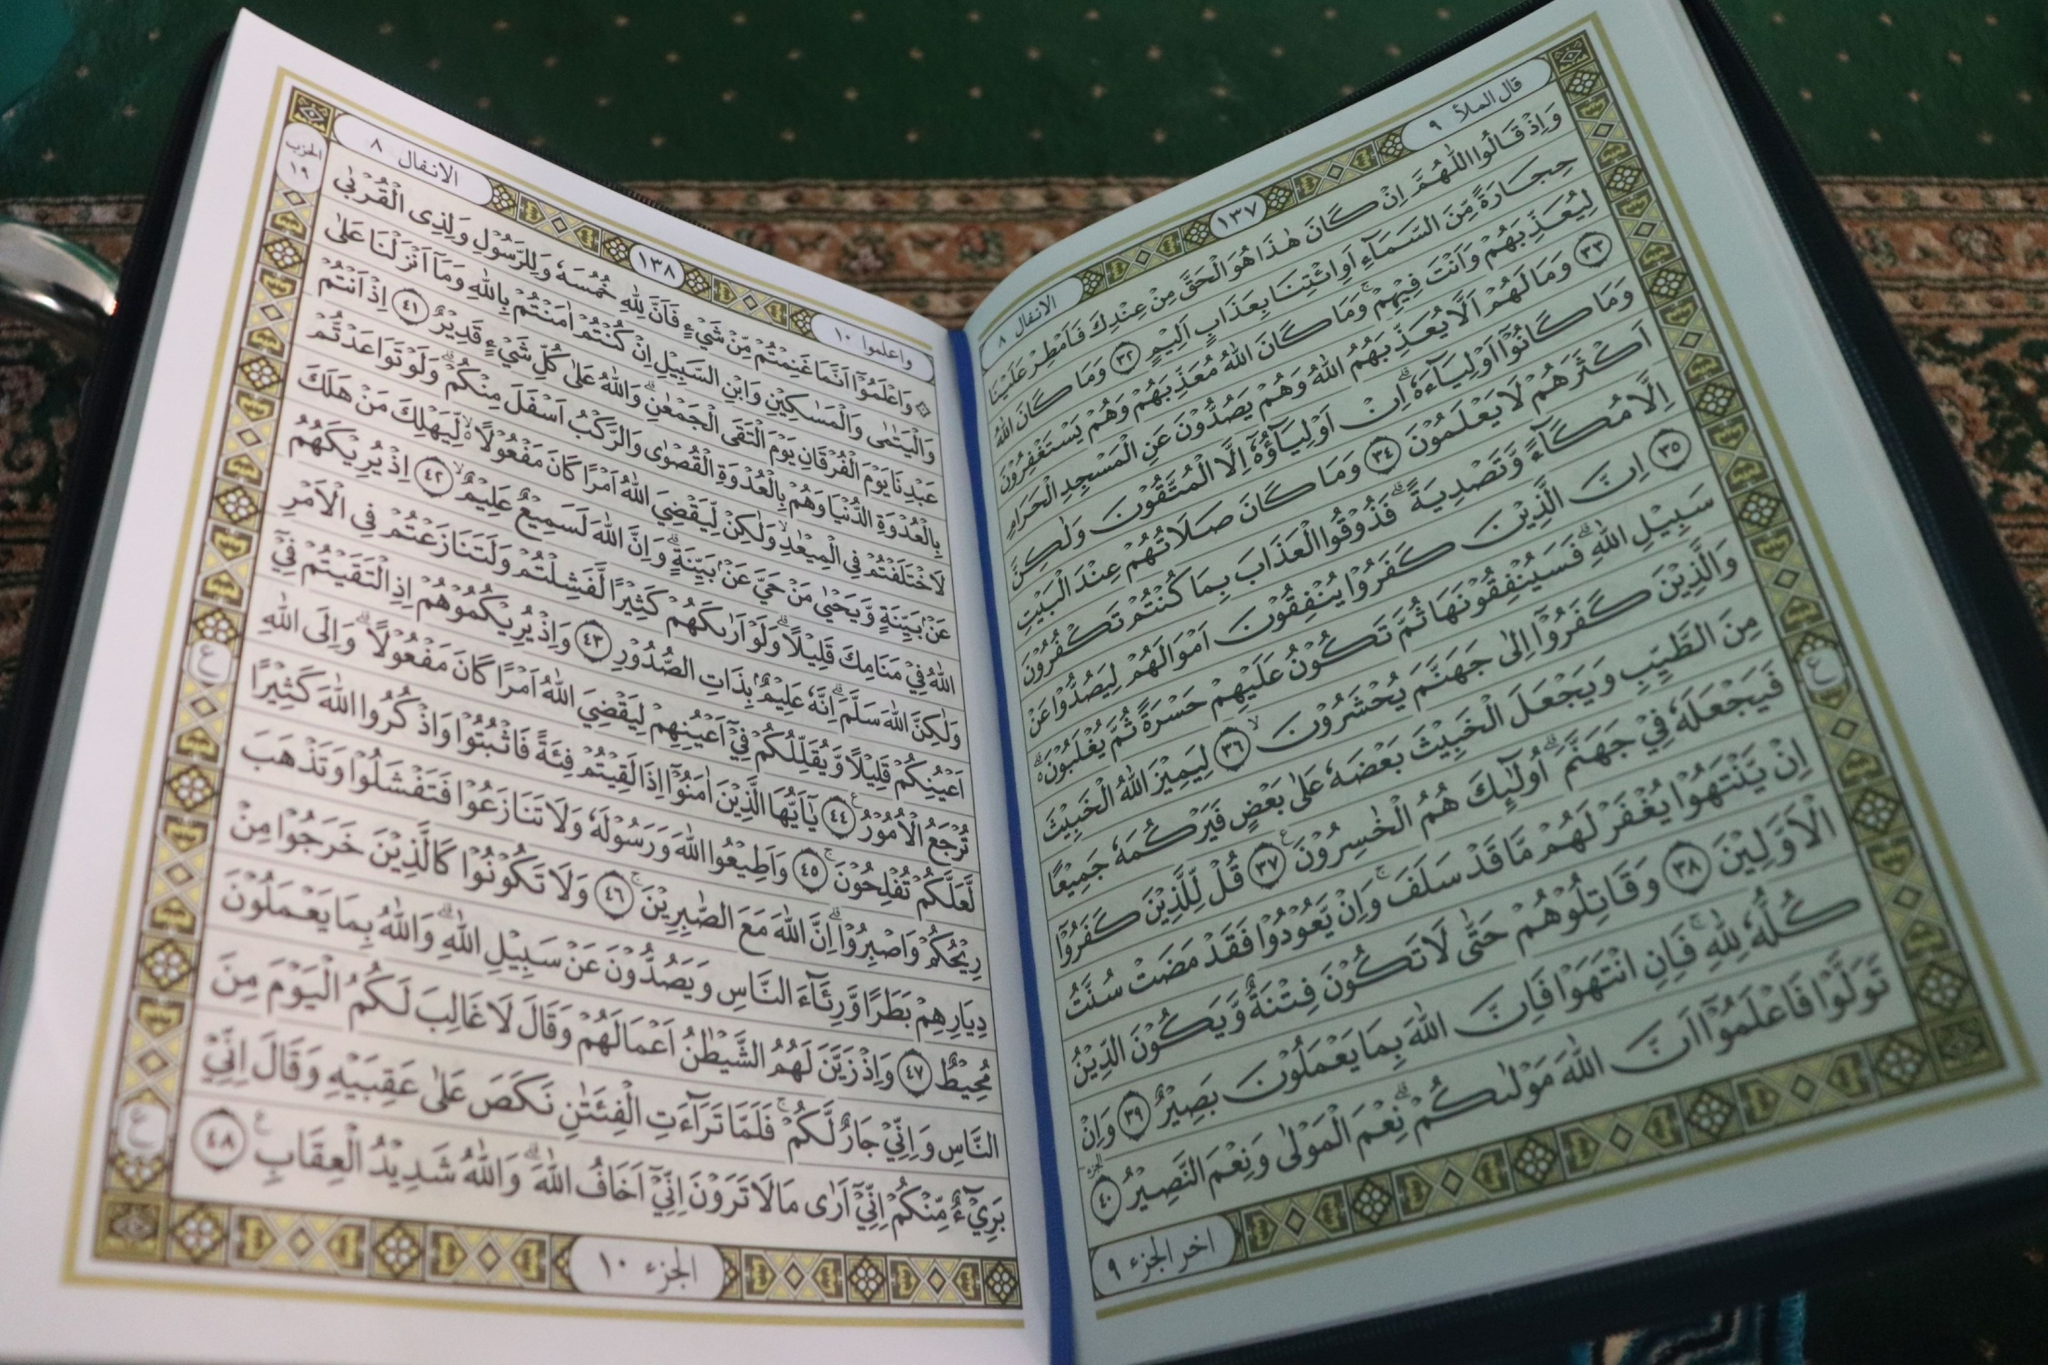What might a futuristic version of this book look like? In a not-so-distant future, the sacred text is preserved within an advanced holographic display device. The book is now an interactive, immersive experience—readers can navigate through the text using voice commands or gestures. Each verse is accompanied by visual and auditory elements that bring its meaning to life: luminous calligraphy floating in mid-air, intricate digital artworks that change with every passage, and ambient sounds that match the themes of peace, contemplation, and divine inspiration. The device can also translate the text into countless languages in real-time and provide historical context or commentary from renowned scholars. This futuristic version maintains the reverence and beauty of the original while adapting to the technology of its time, making the ancient wisdom accessible to a global, tech-savvy audience. 